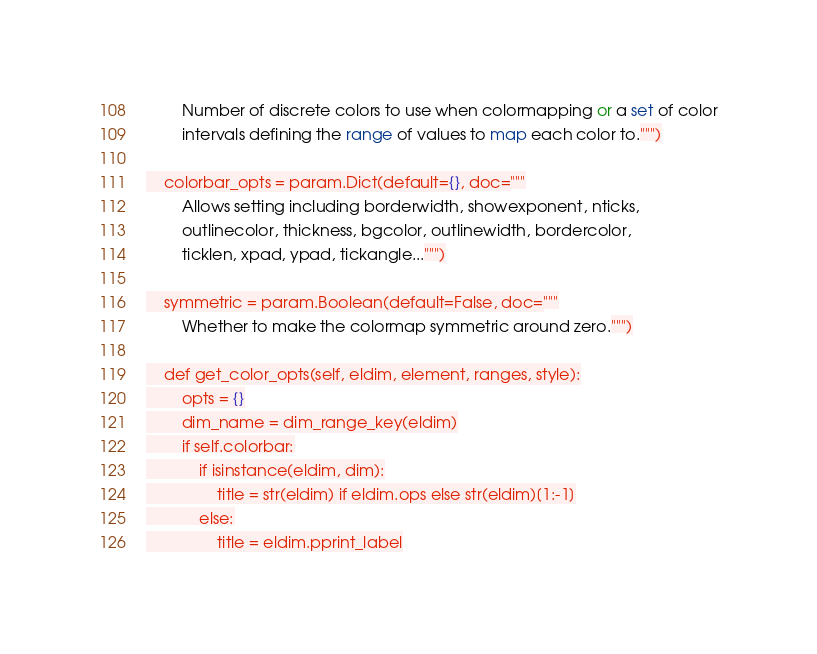Convert code to text. <code><loc_0><loc_0><loc_500><loc_500><_Python_>        Number of discrete colors to use when colormapping or a set of color
        intervals defining the range of values to map each color to.""")

    colorbar_opts = param.Dict(default={}, doc="""
        Allows setting including borderwidth, showexponent, nticks,
        outlinecolor, thickness, bgcolor, outlinewidth, bordercolor,
        ticklen, xpad, ypad, tickangle...""")

    symmetric = param.Boolean(default=False, doc="""
        Whether to make the colormap symmetric around zero.""")

    def get_color_opts(self, eldim, element, ranges, style):
        opts = {}
        dim_name = dim_range_key(eldim)
        if self.colorbar:
            if isinstance(eldim, dim):
                title = str(eldim) if eldim.ops else str(eldim)[1:-1]
            else:
                title = eldim.pprint_label</code> 